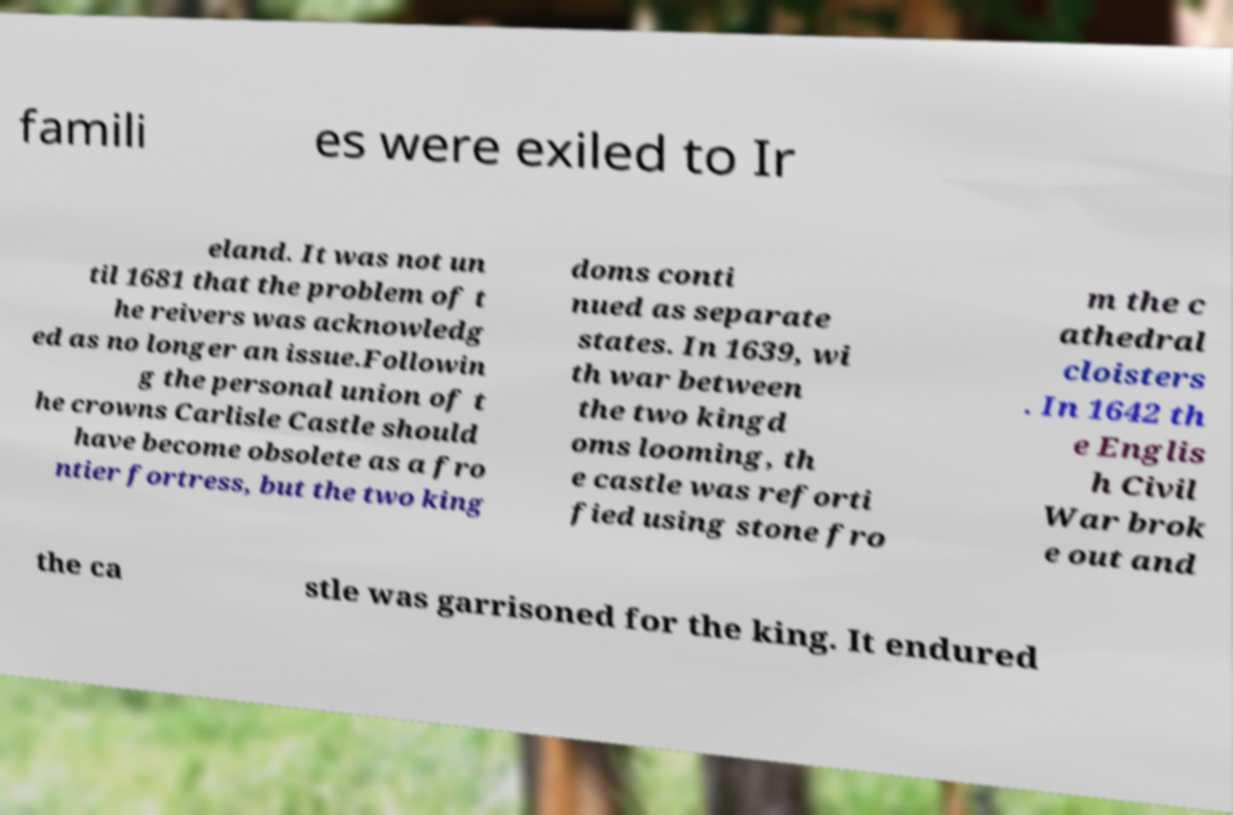What messages or text are displayed in this image? I need them in a readable, typed format. famili es were exiled to Ir eland. It was not un til 1681 that the problem of t he reivers was acknowledg ed as no longer an issue.Followin g the personal union of t he crowns Carlisle Castle should have become obsolete as a fro ntier fortress, but the two king doms conti nued as separate states. In 1639, wi th war between the two kingd oms looming, th e castle was reforti fied using stone fro m the c athedral cloisters . In 1642 th e Englis h Civil War brok e out and the ca stle was garrisoned for the king. It endured 